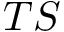Convert formula to latex. <formula><loc_0><loc_0><loc_500><loc_500>T S</formula> 